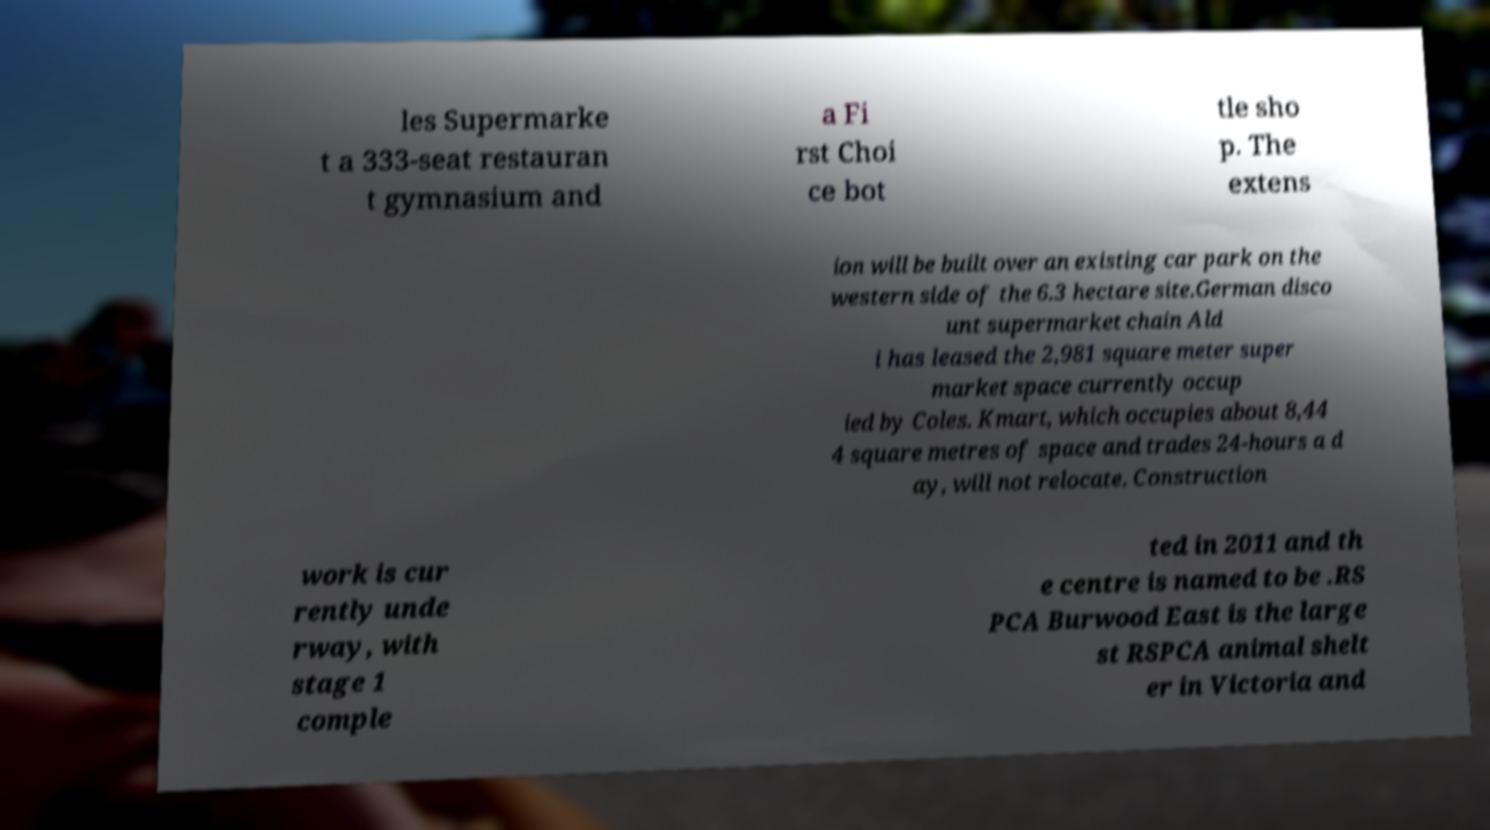Could you assist in decoding the text presented in this image and type it out clearly? les Supermarke t a 333-seat restauran t gymnasium and a Fi rst Choi ce bot tle sho p. The extens ion will be built over an existing car park on the western side of the 6.3 hectare site.German disco unt supermarket chain Ald i has leased the 2,981 square meter super market space currently occup ied by Coles. Kmart, which occupies about 8,44 4 square metres of space and trades 24-hours a d ay, will not relocate. Construction work is cur rently unde rway, with stage 1 comple ted in 2011 and th e centre is named to be .RS PCA Burwood East is the large st RSPCA animal shelt er in Victoria and 